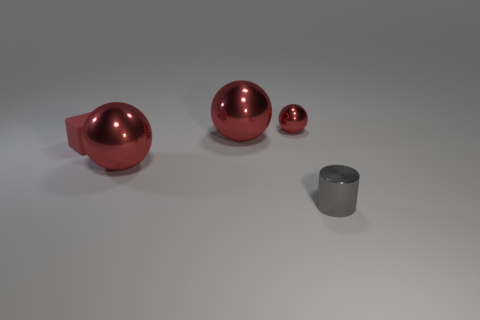Add 5 large shiny objects. How many objects exist? 10 Subtract all large red spheres. How many spheres are left? 1 Subtract 3 red balls. How many objects are left? 2 Subtract all cylinders. How many objects are left? 4 Subtract 1 cubes. How many cubes are left? 0 Subtract all yellow balls. Subtract all brown blocks. How many balls are left? 3 Subtract all small matte cubes. Subtract all tiny gray things. How many objects are left? 3 Add 4 large shiny spheres. How many large shiny spheres are left? 6 Add 2 small gray metallic things. How many small gray metallic things exist? 3 